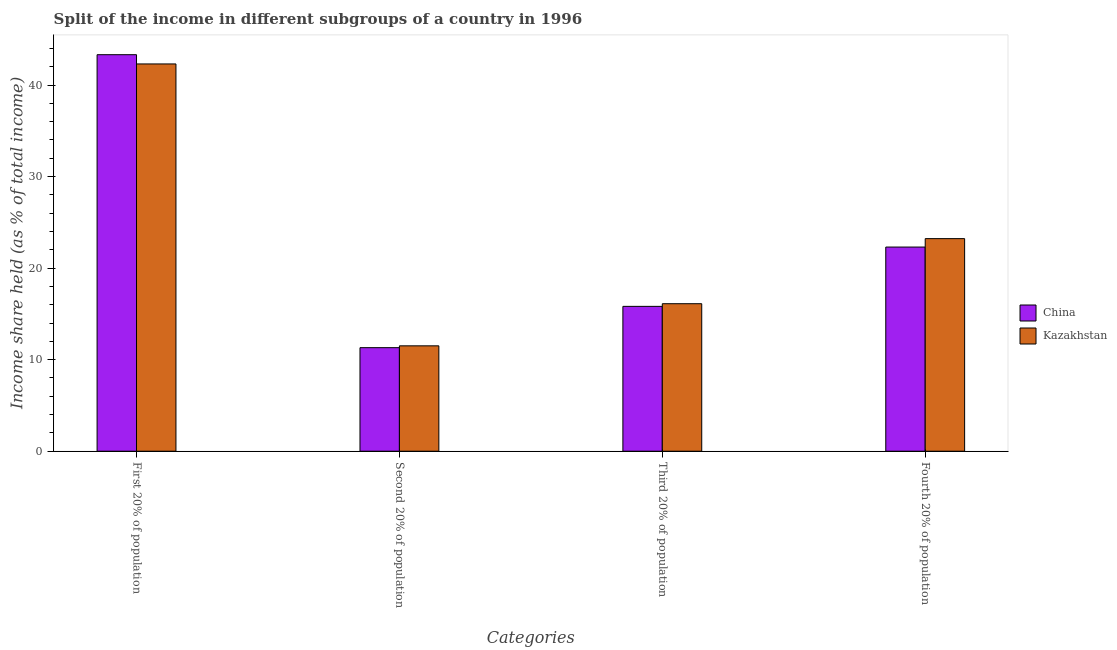How many different coloured bars are there?
Provide a short and direct response. 2. How many groups of bars are there?
Your answer should be very brief. 4. Are the number of bars on each tick of the X-axis equal?
Keep it short and to the point. Yes. What is the label of the 1st group of bars from the left?
Provide a succinct answer. First 20% of population. What is the share of the income held by fourth 20% of the population in Kazakhstan?
Offer a very short reply. 23.22. Across all countries, what is the maximum share of the income held by second 20% of the population?
Provide a short and direct response. 11.51. Across all countries, what is the minimum share of the income held by fourth 20% of the population?
Offer a very short reply. 22.3. In which country was the share of the income held by third 20% of the population maximum?
Give a very brief answer. Kazakhstan. In which country was the share of the income held by third 20% of the population minimum?
Your response must be concise. China. What is the total share of the income held by fourth 20% of the population in the graph?
Provide a succinct answer. 45.52. What is the difference between the share of the income held by third 20% of the population in Kazakhstan and that in China?
Offer a terse response. 0.29. What is the difference between the share of the income held by first 20% of the population in China and the share of the income held by second 20% of the population in Kazakhstan?
Provide a succinct answer. 31.8. What is the average share of the income held by third 20% of the population per country?
Provide a succinct answer. 15.96. What is the difference between the share of the income held by third 20% of the population and share of the income held by second 20% of the population in China?
Your answer should be compact. 4.51. In how many countries, is the share of the income held by first 20% of the population greater than 14 %?
Offer a very short reply. 2. What is the ratio of the share of the income held by second 20% of the population in China to that in Kazakhstan?
Keep it short and to the point. 0.98. Is the difference between the share of the income held by first 20% of the population in Kazakhstan and China greater than the difference between the share of the income held by third 20% of the population in Kazakhstan and China?
Your answer should be very brief. No. What is the difference between the highest and the second highest share of the income held by first 20% of the population?
Offer a terse response. 1.01. What is the difference between the highest and the lowest share of the income held by second 20% of the population?
Give a very brief answer. 0.2. In how many countries, is the share of the income held by first 20% of the population greater than the average share of the income held by first 20% of the population taken over all countries?
Make the answer very short. 1. What does the 1st bar from the left in First 20% of population represents?
Provide a succinct answer. China. What does the 2nd bar from the right in Fourth 20% of population represents?
Give a very brief answer. China. Are all the bars in the graph horizontal?
Your answer should be very brief. No. What is the difference between two consecutive major ticks on the Y-axis?
Your response must be concise. 10. Does the graph contain any zero values?
Offer a terse response. No. Does the graph contain grids?
Offer a very short reply. No. How many legend labels are there?
Offer a terse response. 2. What is the title of the graph?
Your answer should be compact. Split of the income in different subgroups of a country in 1996. What is the label or title of the X-axis?
Your answer should be very brief. Categories. What is the label or title of the Y-axis?
Ensure brevity in your answer.  Income share held (as % of total income). What is the Income share held (as % of total income) in China in First 20% of population?
Offer a very short reply. 43.31. What is the Income share held (as % of total income) in Kazakhstan in First 20% of population?
Provide a succinct answer. 42.3. What is the Income share held (as % of total income) in China in Second 20% of population?
Make the answer very short. 11.31. What is the Income share held (as % of total income) of Kazakhstan in Second 20% of population?
Make the answer very short. 11.51. What is the Income share held (as % of total income) of China in Third 20% of population?
Ensure brevity in your answer.  15.82. What is the Income share held (as % of total income) of Kazakhstan in Third 20% of population?
Your answer should be compact. 16.11. What is the Income share held (as % of total income) of China in Fourth 20% of population?
Ensure brevity in your answer.  22.3. What is the Income share held (as % of total income) in Kazakhstan in Fourth 20% of population?
Keep it short and to the point. 23.22. Across all Categories, what is the maximum Income share held (as % of total income) in China?
Offer a very short reply. 43.31. Across all Categories, what is the maximum Income share held (as % of total income) in Kazakhstan?
Your response must be concise. 42.3. Across all Categories, what is the minimum Income share held (as % of total income) of China?
Your answer should be very brief. 11.31. Across all Categories, what is the minimum Income share held (as % of total income) of Kazakhstan?
Make the answer very short. 11.51. What is the total Income share held (as % of total income) of China in the graph?
Offer a very short reply. 92.74. What is the total Income share held (as % of total income) in Kazakhstan in the graph?
Offer a terse response. 93.14. What is the difference between the Income share held (as % of total income) of Kazakhstan in First 20% of population and that in Second 20% of population?
Provide a succinct answer. 30.79. What is the difference between the Income share held (as % of total income) in China in First 20% of population and that in Third 20% of population?
Keep it short and to the point. 27.49. What is the difference between the Income share held (as % of total income) of Kazakhstan in First 20% of population and that in Third 20% of population?
Your answer should be compact. 26.19. What is the difference between the Income share held (as % of total income) in China in First 20% of population and that in Fourth 20% of population?
Your answer should be compact. 21.01. What is the difference between the Income share held (as % of total income) in Kazakhstan in First 20% of population and that in Fourth 20% of population?
Provide a short and direct response. 19.08. What is the difference between the Income share held (as % of total income) in China in Second 20% of population and that in Third 20% of population?
Keep it short and to the point. -4.51. What is the difference between the Income share held (as % of total income) in China in Second 20% of population and that in Fourth 20% of population?
Provide a succinct answer. -10.99. What is the difference between the Income share held (as % of total income) of Kazakhstan in Second 20% of population and that in Fourth 20% of population?
Your answer should be very brief. -11.71. What is the difference between the Income share held (as % of total income) of China in Third 20% of population and that in Fourth 20% of population?
Your answer should be compact. -6.48. What is the difference between the Income share held (as % of total income) of Kazakhstan in Third 20% of population and that in Fourth 20% of population?
Offer a terse response. -7.11. What is the difference between the Income share held (as % of total income) in China in First 20% of population and the Income share held (as % of total income) in Kazakhstan in Second 20% of population?
Your response must be concise. 31.8. What is the difference between the Income share held (as % of total income) of China in First 20% of population and the Income share held (as % of total income) of Kazakhstan in Third 20% of population?
Your response must be concise. 27.2. What is the difference between the Income share held (as % of total income) in China in First 20% of population and the Income share held (as % of total income) in Kazakhstan in Fourth 20% of population?
Keep it short and to the point. 20.09. What is the difference between the Income share held (as % of total income) in China in Second 20% of population and the Income share held (as % of total income) in Kazakhstan in Third 20% of population?
Provide a succinct answer. -4.8. What is the difference between the Income share held (as % of total income) of China in Second 20% of population and the Income share held (as % of total income) of Kazakhstan in Fourth 20% of population?
Keep it short and to the point. -11.91. What is the average Income share held (as % of total income) in China per Categories?
Your answer should be compact. 23.18. What is the average Income share held (as % of total income) of Kazakhstan per Categories?
Make the answer very short. 23.29. What is the difference between the Income share held (as % of total income) of China and Income share held (as % of total income) of Kazakhstan in First 20% of population?
Give a very brief answer. 1.01. What is the difference between the Income share held (as % of total income) of China and Income share held (as % of total income) of Kazakhstan in Second 20% of population?
Offer a terse response. -0.2. What is the difference between the Income share held (as % of total income) in China and Income share held (as % of total income) in Kazakhstan in Third 20% of population?
Offer a very short reply. -0.29. What is the difference between the Income share held (as % of total income) of China and Income share held (as % of total income) of Kazakhstan in Fourth 20% of population?
Your response must be concise. -0.92. What is the ratio of the Income share held (as % of total income) of China in First 20% of population to that in Second 20% of population?
Your response must be concise. 3.83. What is the ratio of the Income share held (as % of total income) in Kazakhstan in First 20% of population to that in Second 20% of population?
Give a very brief answer. 3.68. What is the ratio of the Income share held (as % of total income) in China in First 20% of population to that in Third 20% of population?
Your answer should be very brief. 2.74. What is the ratio of the Income share held (as % of total income) in Kazakhstan in First 20% of population to that in Third 20% of population?
Provide a succinct answer. 2.63. What is the ratio of the Income share held (as % of total income) in China in First 20% of population to that in Fourth 20% of population?
Your answer should be very brief. 1.94. What is the ratio of the Income share held (as % of total income) in Kazakhstan in First 20% of population to that in Fourth 20% of population?
Your answer should be compact. 1.82. What is the ratio of the Income share held (as % of total income) in China in Second 20% of population to that in Third 20% of population?
Your response must be concise. 0.71. What is the ratio of the Income share held (as % of total income) in Kazakhstan in Second 20% of population to that in Third 20% of population?
Your answer should be very brief. 0.71. What is the ratio of the Income share held (as % of total income) of China in Second 20% of population to that in Fourth 20% of population?
Make the answer very short. 0.51. What is the ratio of the Income share held (as % of total income) in Kazakhstan in Second 20% of population to that in Fourth 20% of population?
Your answer should be very brief. 0.5. What is the ratio of the Income share held (as % of total income) in China in Third 20% of population to that in Fourth 20% of population?
Keep it short and to the point. 0.71. What is the ratio of the Income share held (as % of total income) of Kazakhstan in Third 20% of population to that in Fourth 20% of population?
Keep it short and to the point. 0.69. What is the difference between the highest and the second highest Income share held (as % of total income) of China?
Offer a very short reply. 21.01. What is the difference between the highest and the second highest Income share held (as % of total income) in Kazakhstan?
Make the answer very short. 19.08. What is the difference between the highest and the lowest Income share held (as % of total income) in China?
Ensure brevity in your answer.  32. What is the difference between the highest and the lowest Income share held (as % of total income) of Kazakhstan?
Make the answer very short. 30.79. 